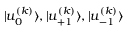<formula> <loc_0><loc_0><loc_500><loc_500>{ | u _ { 0 } ^ { ( k ) } \rangle } , { | u _ { + 1 } ^ { ( k ) } \rangle } , { | u _ { - 1 } ^ { ( k ) } \rangle }</formula> 